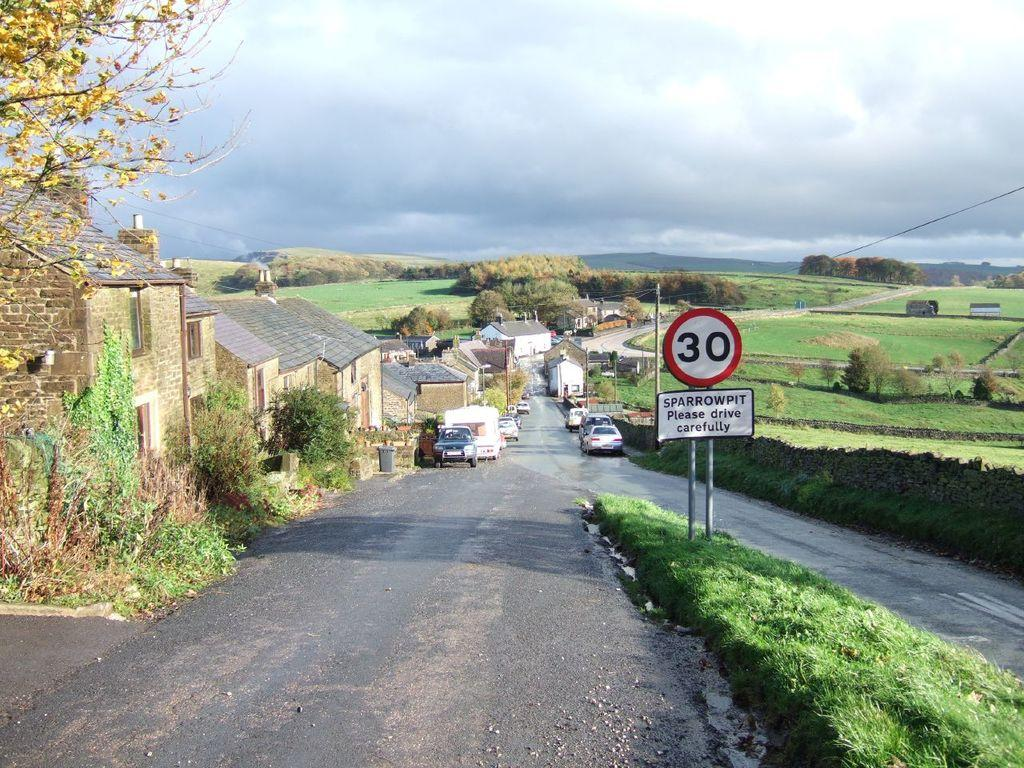<image>
Describe the image concisely. Cars and small buildings line a road in a countryside setting, and a posted street sign announces a 30 speed limit, and "SPARROWPIT" and cautions drivers to, "please drive carefully." 